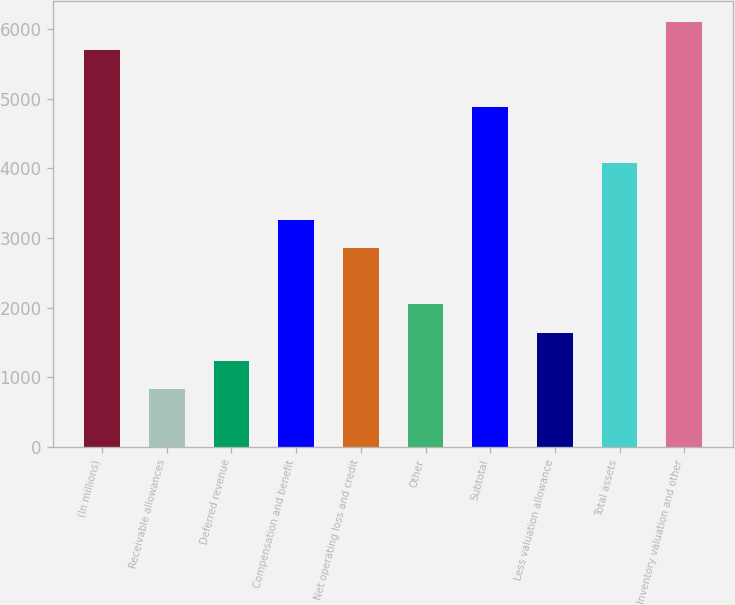Convert chart to OTSL. <chart><loc_0><loc_0><loc_500><loc_500><bar_chart><fcel>(In millions)<fcel>Receivable allowances<fcel>Deferred revenue<fcel>Compensation and benefit<fcel>Net operating loss and credit<fcel>Other<fcel>Subtotal<fcel>Less valuation allowance<fcel>Total assets<fcel>Inventory valuation and other<nl><fcel>5697.4<fcel>830.2<fcel>1235.8<fcel>3263.8<fcel>2858.2<fcel>2047<fcel>4886.2<fcel>1641.4<fcel>4075<fcel>6103<nl></chart> 